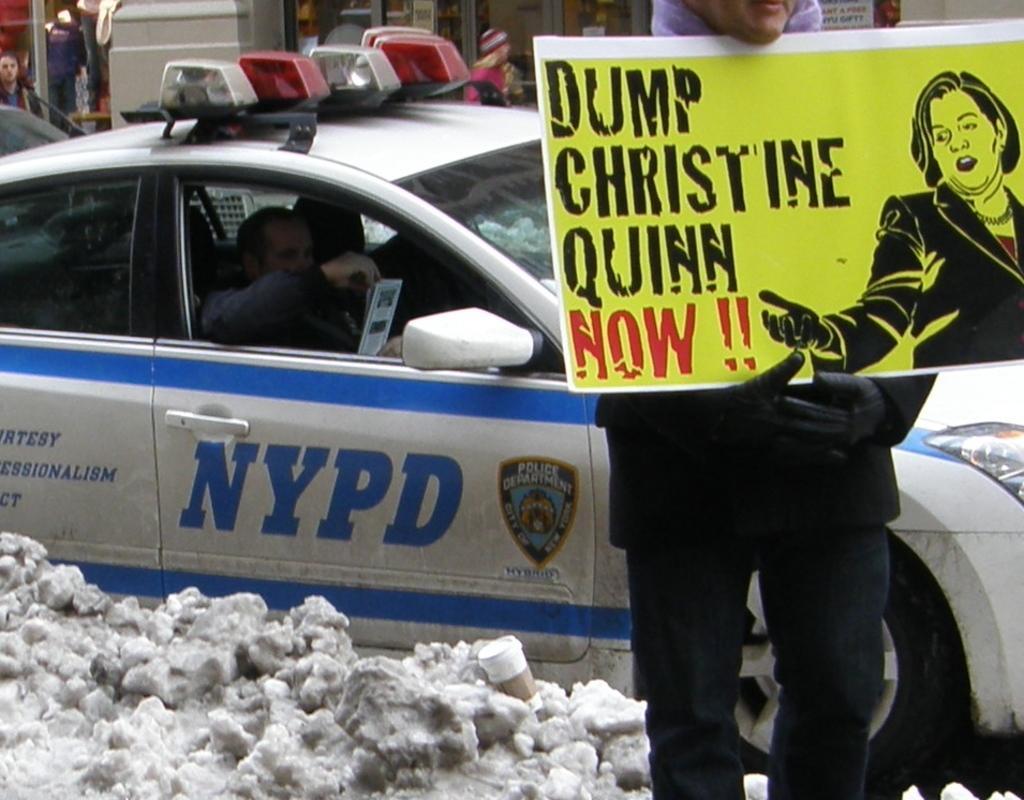How would you summarize this image in a sentence or two? This is the picture of a person who is holding the note and beside him there is a car and some snow on the floor. 